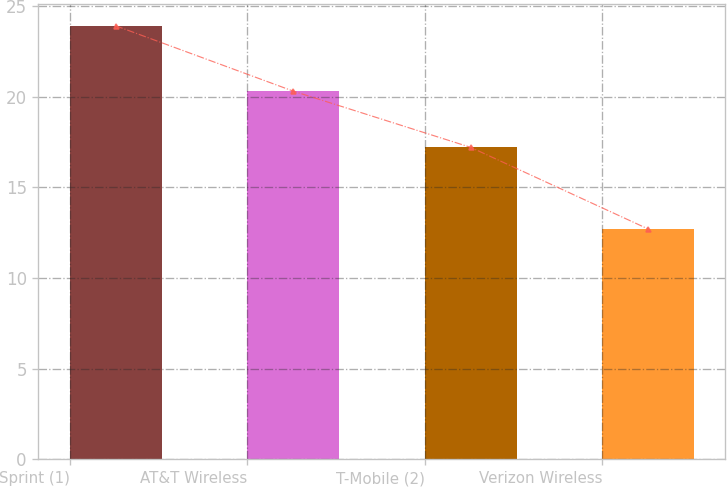Convert chart. <chart><loc_0><loc_0><loc_500><loc_500><bar_chart><fcel>Sprint (1)<fcel>AT&T Wireless<fcel>T-Mobile (2)<fcel>Verizon Wireless<nl><fcel>23.9<fcel>20.3<fcel>17.2<fcel>12.7<nl></chart> 